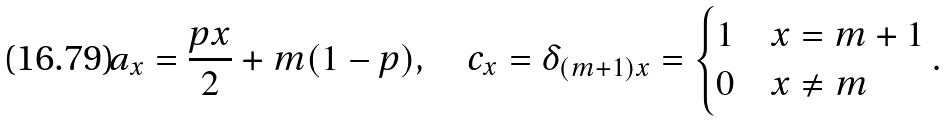Convert formula to latex. <formula><loc_0><loc_0><loc_500><loc_500>a _ { x } = \frac { p x } { 2 } + m ( 1 - p ) , \quad c _ { x } = \delta _ { ( m + 1 ) x } = \begin{cases} 1 & x = m + 1 \\ 0 & x \neq m \end{cases} .</formula> 